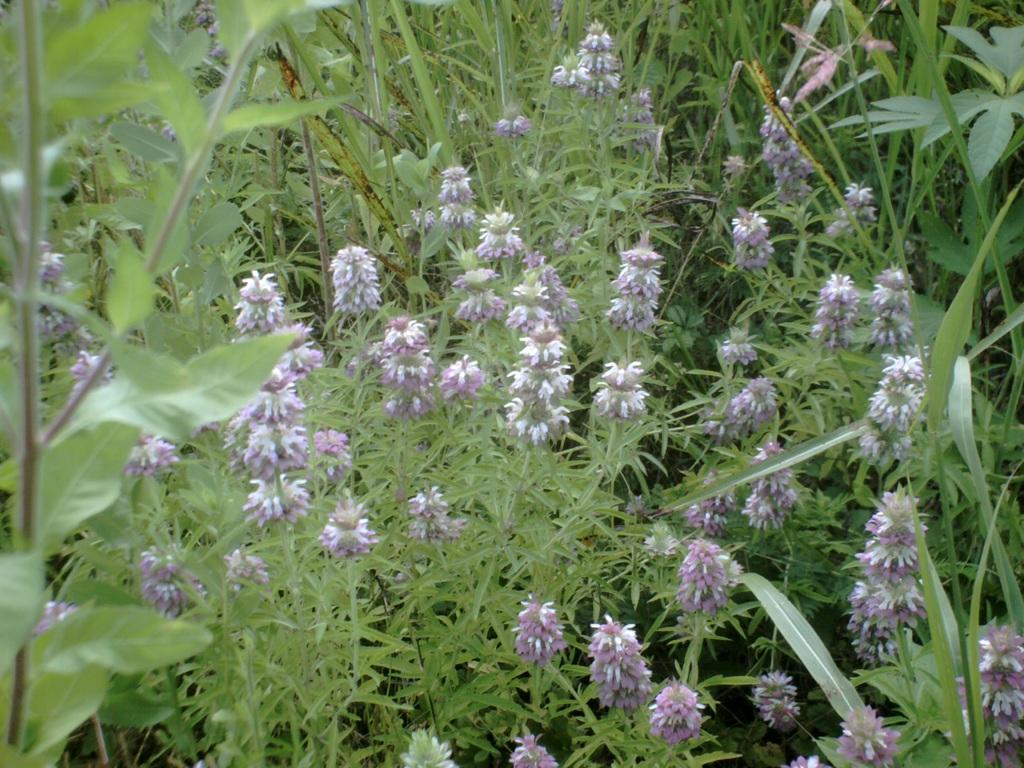What objects are on the ground in the image? There are planets and flowers on the ground in the image. Can you describe the planets in the image? The planets are depicted on the ground, but no further details about their appearance or characteristics are provided. What type of vegetation is present on the ground in the image? There are flowers on the ground in the image. Where is the nearest store to the location depicted in the image? There is no information about the location or the presence of a store in the image, so this question cannot be answered definitively. 